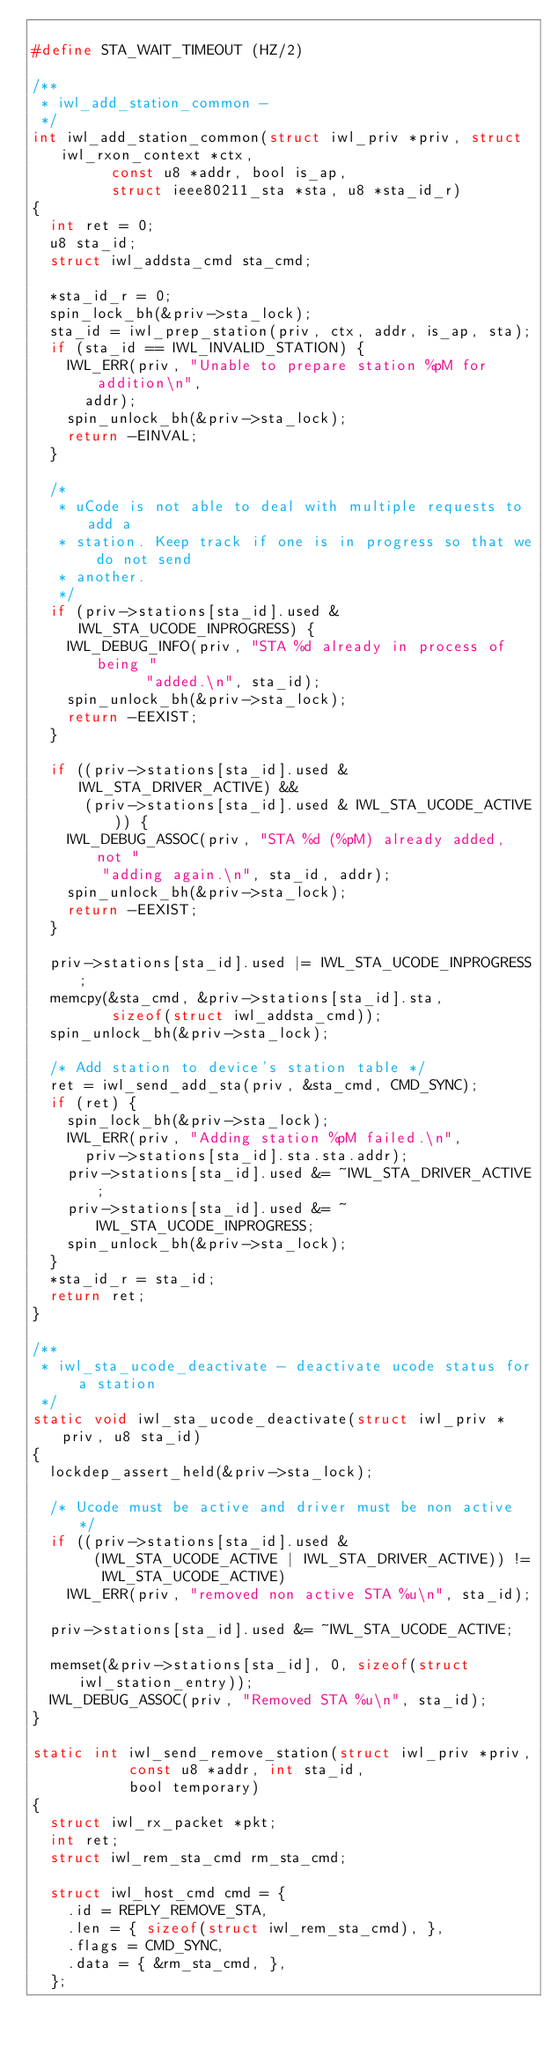Convert code to text. <code><loc_0><loc_0><loc_500><loc_500><_C_>
#define STA_WAIT_TIMEOUT (HZ/2)

/**
 * iwl_add_station_common -
 */
int iwl_add_station_common(struct iwl_priv *priv, struct iwl_rxon_context *ctx,
			   const u8 *addr, bool is_ap,
			   struct ieee80211_sta *sta, u8 *sta_id_r)
{
	int ret = 0;
	u8 sta_id;
	struct iwl_addsta_cmd sta_cmd;

	*sta_id_r = 0;
	spin_lock_bh(&priv->sta_lock);
	sta_id = iwl_prep_station(priv, ctx, addr, is_ap, sta);
	if (sta_id == IWL_INVALID_STATION) {
		IWL_ERR(priv, "Unable to prepare station %pM for addition\n",
			addr);
		spin_unlock_bh(&priv->sta_lock);
		return -EINVAL;
	}

	/*
	 * uCode is not able to deal with multiple requests to add a
	 * station. Keep track if one is in progress so that we do not send
	 * another.
	 */
	if (priv->stations[sta_id].used & IWL_STA_UCODE_INPROGRESS) {
		IWL_DEBUG_INFO(priv, "STA %d already in process of being "
			       "added.\n", sta_id);
		spin_unlock_bh(&priv->sta_lock);
		return -EEXIST;
	}

	if ((priv->stations[sta_id].used & IWL_STA_DRIVER_ACTIVE) &&
	    (priv->stations[sta_id].used & IWL_STA_UCODE_ACTIVE)) {
		IWL_DEBUG_ASSOC(priv, "STA %d (%pM) already added, not "
				"adding again.\n", sta_id, addr);
		spin_unlock_bh(&priv->sta_lock);
		return -EEXIST;
	}

	priv->stations[sta_id].used |= IWL_STA_UCODE_INPROGRESS;
	memcpy(&sta_cmd, &priv->stations[sta_id].sta,
	       sizeof(struct iwl_addsta_cmd));
	spin_unlock_bh(&priv->sta_lock);

	/* Add station to device's station table */
	ret = iwl_send_add_sta(priv, &sta_cmd, CMD_SYNC);
	if (ret) {
		spin_lock_bh(&priv->sta_lock);
		IWL_ERR(priv, "Adding station %pM failed.\n",
			priv->stations[sta_id].sta.sta.addr);
		priv->stations[sta_id].used &= ~IWL_STA_DRIVER_ACTIVE;
		priv->stations[sta_id].used &= ~IWL_STA_UCODE_INPROGRESS;
		spin_unlock_bh(&priv->sta_lock);
	}
	*sta_id_r = sta_id;
	return ret;
}

/**
 * iwl_sta_ucode_deactivate - deactivate ucode status for a station
 */
static void iwl_sta_ucode_deactivate(struct iwl_priv *priv, u8 sta_id)
{
	lockdep_assert_held(&priv->sta_lock);

	/* Ucode must be active and driver must be non active */
	if ((priv->stations[sta_id].used &
	     (IWL_STA_UCODE_ACTIVE | IWL_STA_DRIVER_ACTIVE)) !=
	      IWL_STA_UCODE_ACTIVE)
		IWL_ERR(priv, "removed non active STA %u\n", sta_id);

	priv->stations[sta_id].used &= ~IWL_STA_UCODE_ACTIVE;

	memset(&priv->stations[sta_id], 0, sizeof(struct iwl_station_entry));
	IWL_DEBUG_ASSOC(priv, "Removed STA %u\n", sta_id);
}

static int iwl_send_remove_station(struct iwl_priv *priv,
				   const u8 *addr, int sta_id,
				   bool temporary)
{
	struct iwl_rx_packet *pkt;
	int ret;
	struct iwl_rem_sta_cmd rm_sta_cmd;

	struct iwl_host_cmd cmd = {
		.id = REPLY_REMOVE_STA,
		.len = { sizeof(struct iwl_rem_sta_cmd), },
		.flags = CMD_SYNC,
		.data = { &rm_sta_cmd, },
	};
</code> 